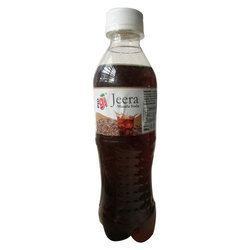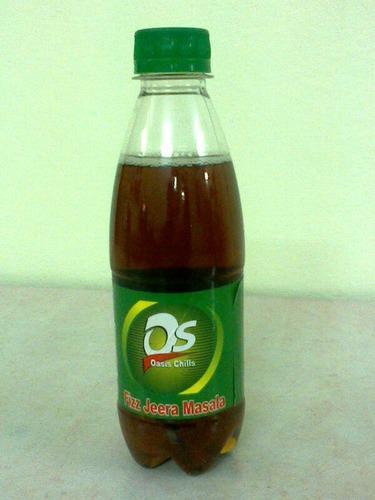The first image is the image on the left, the second image is the image on the right. Considering the images on both sides, is "There are at least seven bottles in total." valid? Answer yes or no. No. The first image is the image on the left, the second image is the image on the right. For the images shown, is this caption "One image shows five upright identical bottles arranged in a V-formation." true? Answer yes or no. No. 